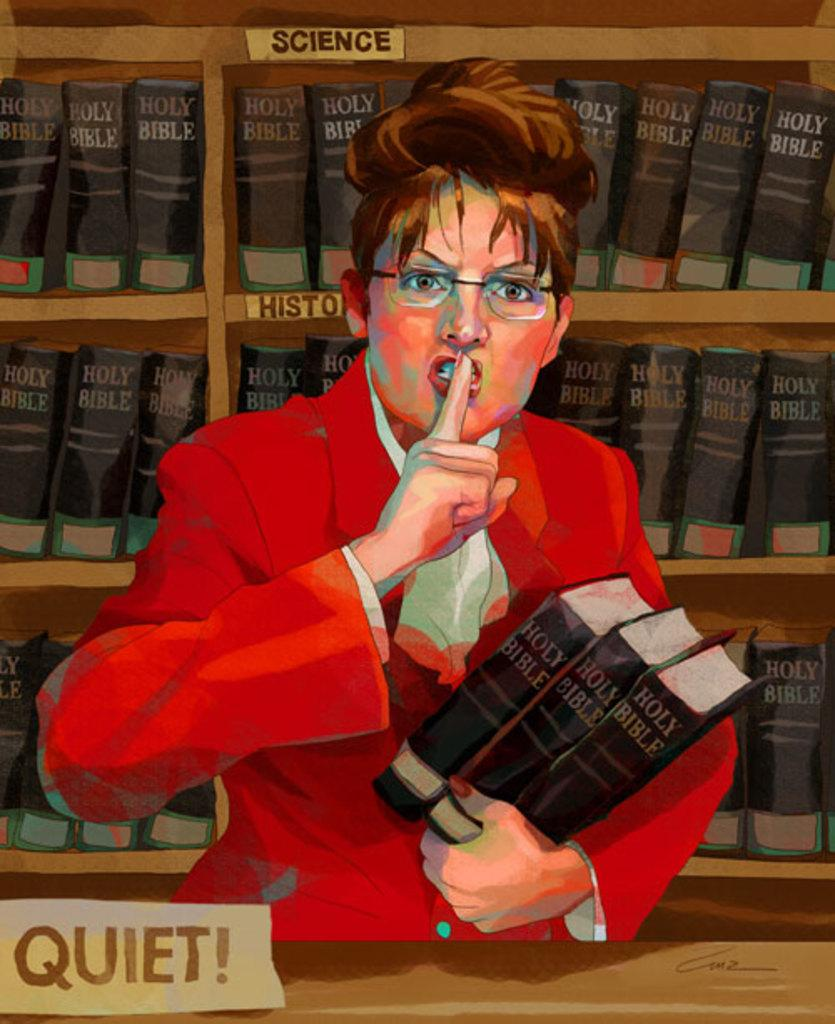Who is the main subject in the image? There is a woman in the image. What is the woman wearing? The woman is wearing a red jacket. What is the woman holding in the image? The woman is holding books. What can be seen in the background of the image? There is a bookshelf in the background of the image. How is the image depicted? The image is in a cartoon style. What type of industry is depicted in the image? There is no industry depicted in the image; it features a woman holding books in a cartoon style. 